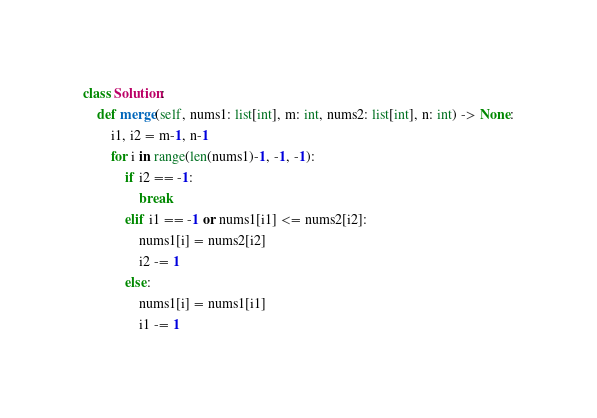<code> <loc_0><loc_0><loc_500><loc_500><_Python_>class Solution:
    def merge(self, nums1: list[int], m: int, nums2: list[int], n: int) -> None:
        i1, i2 = m-1, n-1
        for i in range(len(nums1)-1, -1, -1):
            if i2 == -1:
                break
            elif i1 == -1 or nums1[i1] <= nums2[i2]:
                nums1[i] = nums2[i2]
                i2 -= 1
            else:
                nums1[i] = nums1[i1]
                i1 -= 1
</code> 